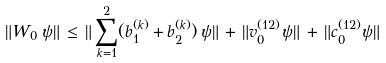<formula> <loc_0><loc_0><loc_500><loc_500>\| W _ { 0 } \, \psi \| \, \leq \, \| \sum _ { k = 1 } ^ { 2 } ( b _ { 1 } ^ { ( k ) } + b _ { 2 } ^ { ( k ) } ) \, \psi \| \, + \, \| v _ { 0 } ^ { ( 1 2 ) } \psi \| \, + \, \| c _ { 0 } ^ { ( 1 2 ) } \psi \|</formula> 